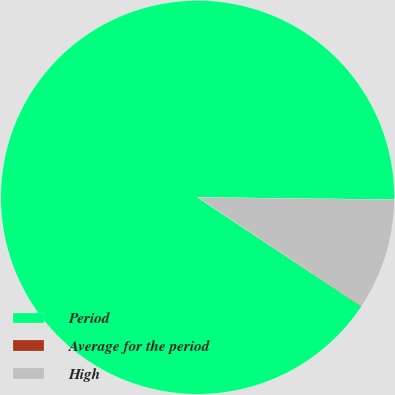Convert chart. <chart><loc_0><loc_0><loc_500><loc_500><pie_chart><fcel>Period<fcel>Average for the period<fcel>High<nl><fcel>90.83%<fcel>0.05%<fcel>9.12%<nl></chart> 